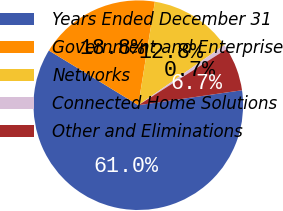<chart> <loc_0><loc_0><loc_500><loc_500><pie_chart><fcel>Years Ended December 31<fcel>Government and Enterprise<fcel>Networks<fcel>Connected Home Solutions<fcel>Other and Eliminations<nl><fcel>61.01%<fcel>18.79%<fcel>12.76%<fcel>0.7%<fcel>6.73%<nl></chart> 